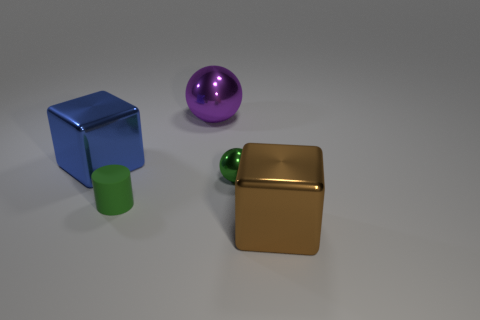Add 4 big blue things. How many objects exist? 9 Subtract all spheres. How many objects are left? 3 Add 4 cylinders. How many cylinders are left? 5 Add 4 green cubes. How many green cubes exist? 4 Subtract 0 brown cylinders. How many objects are left? 5 Subtract all large purple shiny things. Subtract all small balls. How many objects are left? 3 